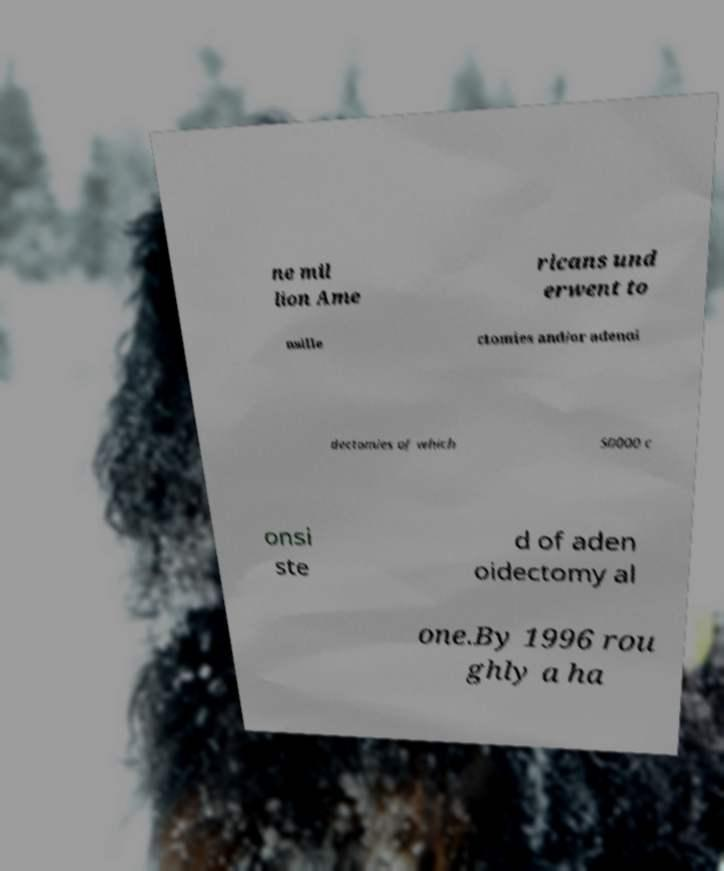Could you extract and type out the text from this image? ne mil lion Ame ricans und erwent to nsille ctomies and/or adenoi dectomies of which 50000 c onsi ste d of aden oidectomy al one.By 1996 rou ghly a ha 